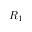<formula> <loc_0><loc_0><loc_500><loc_500>R _ { 1 }</formula> 